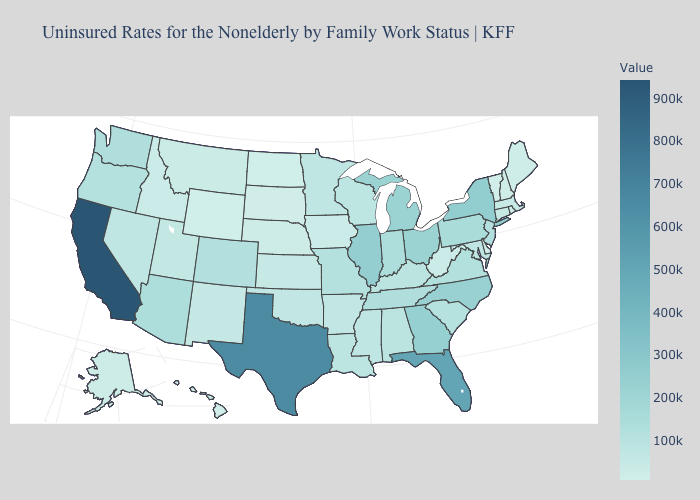Which states have the highest value in the USA?
Write a very short answer. California. Among the states that border Wyoming , which have the highest value?
Short answer required. Colorado. Does Connecticut have a higher value than New York?
Give a very brief answer. No. 